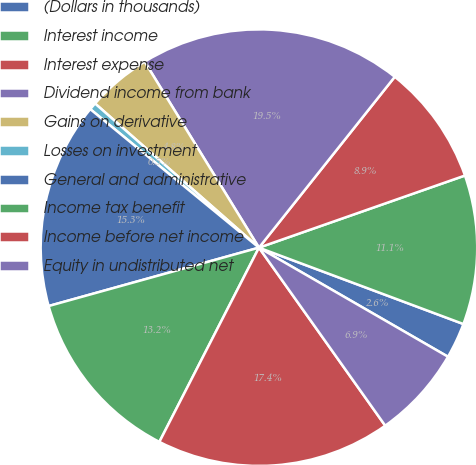Convert chart to OTSL. <chart><loc_0><loc_0><loc_500><loc_500><pie_chart><fcel>(Dollars in thousands)<fcel>Interest income<fcel>Interest expense<fcel>Dividend income from bank<fcel>Gains on derivative<fcel>Losses on investment<fcel>General and administrative<fcel>Income tax benefit<fcel>Income before net income<fcel>Equity in undistributed net<nl><fcel>2.64%<fcel>11.05%<fcel>8.95%<fcel>19.46%<fcel>4.75%<fcel>0.54%<fcel>15.25%<fcel>13.15%<fcel>17.36%<fcel>6.85%<nl></chart> 